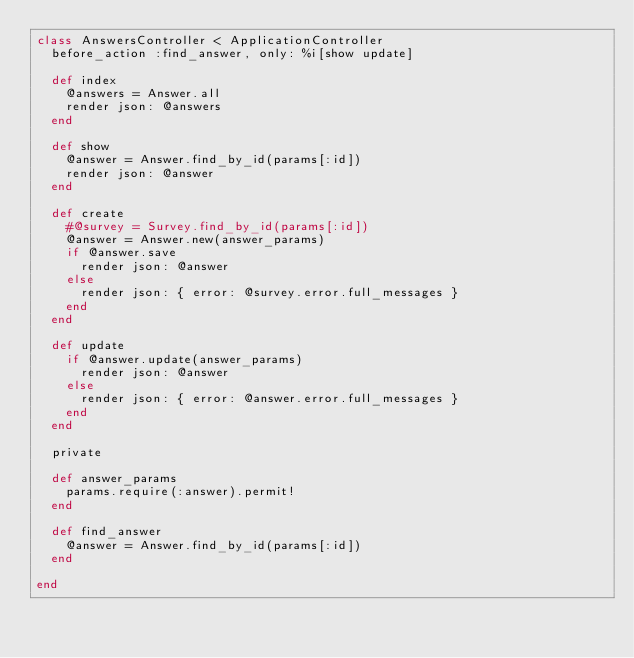<code> <loc_0><loc_0><loc_500><loc_500><_Ruby_>class AnswersController < ApplicationController
  before_action :find_answer, only: %i[show update]

  def index
    @answers = Answer.all
    render json: @answers
  end

  def show
    @answer = Answer.find_by_id(params[:id])
    render json: @answer
  end

  def create
    #@survey = Survey.find_by_id(params[:id])
    @answer = Answer.new(answer_params)
    if @answer.save
      render json: @answer
    else
      render json: { error: @survey.error.full_messages }
    end
  end

  def update
    if @answer.update(answer_params)
      render json: @answer
    else
      render json: { error: @answer.error.full_messages }
    end
  end

  private

  def answer_params
    params.require(:answer).permit!
  end

  def find_answer
    @answer = Answer.find_by_id(params[:id])
  end

end
</code> 